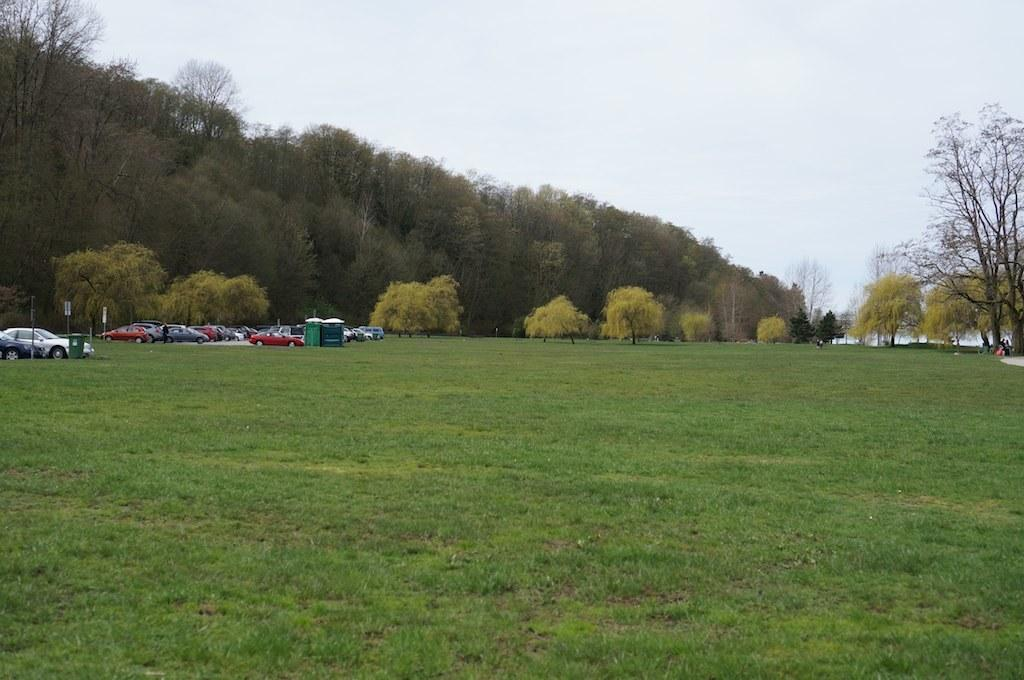What is located on the grass in the image? There are vehicles on the grass in the image. What can be seen besides the vehicles on the grass? There are sign boards and trees in the image. What is the natural element visible in the image? There is water visible in the image. Can you tell me how many crooks are depicted in the image? There are no crooks present in the image. What type of wish can be granted by the water in the image? There is no mention of wishes or any magical elements in the image; it simply shows water. 